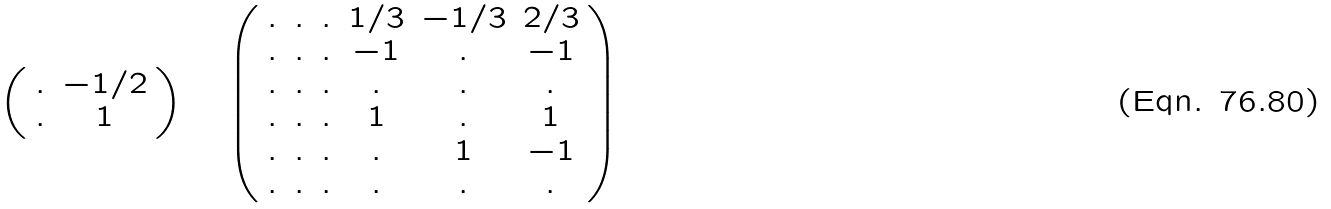Convert formula to latex. <formula><loc_0><loc_0><loc_500><loc_500>\left ( \begin{array} { c c } . & - 1 / 2 \\ . & 1 \\ \end{array} \right ) \quad \left ( \begin{array} { c c c c c c } . & . & . & 1 / 3 & - 1 / 3 & 2 / 3 \\ . & . & . & - 1 & . & - 1 \\ . & . & . & . & . & . \\ . & . & . & 1 & . & 1 \\ . & . & . & . & 1 & - 1 \\ . & . & . & . & . & . \\ \end{array} \right )</formula> 